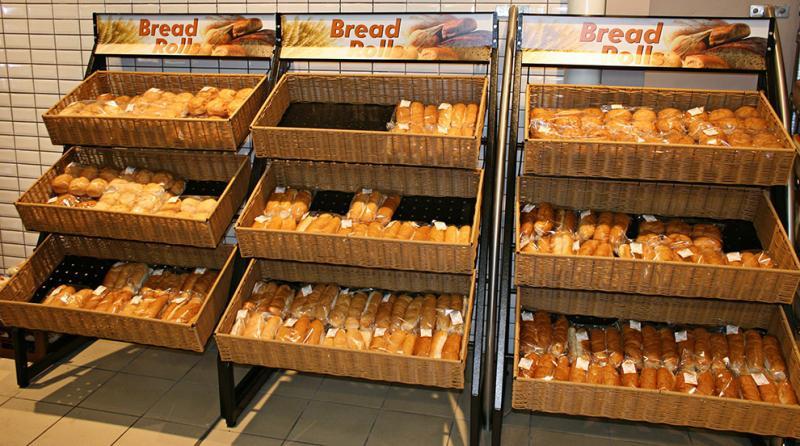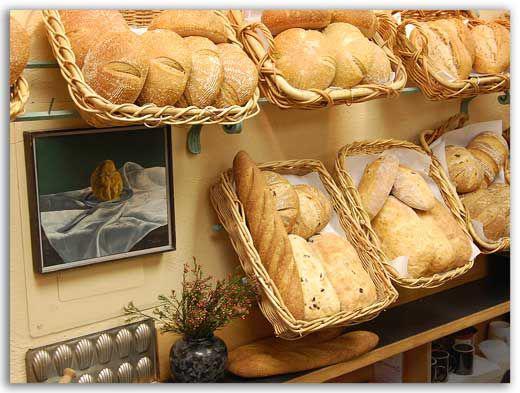The first image is the image on the left, the second image is the image on the right. Considering the images on both sides, is "Both images contain labels and prices." valid? Answer yes or no. No. The first image is the image on the left, the second image is the image on the right. For the images shown, is this caption "The left image shows sloping tiers of tan rectangular trays that hold bakery items." true? Answer yes or no. Yes. 